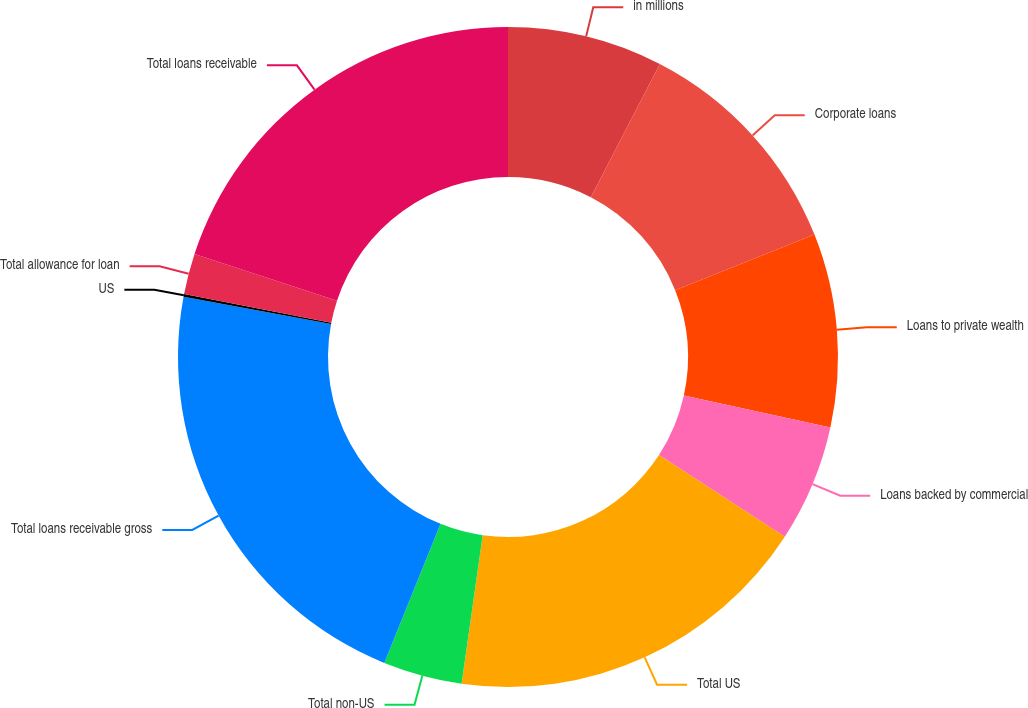Convert chart to OTSL. <chart><loc_0><loc_0><loc_500><loc_500><pie_chart><fcel>in millions<fcel>Corporate loans<fcel>Loans to private wealth<fcel>Loans backed by commercial<fcel>Total US<fcel>Total non-US<fcel>Total loans receivable gross<fcel>US<fcel>Total allowance for loan<fcel>Total loans receivable<nl><fcel>7.61%<fcel>11.34%<fcel>9.47%<fcel>5.74%<fcel>18.08%<fcel>3.87%<fcel>21.81%<fcel>0.13%<fcel>2.0%<fcel>19.94%<nl></chart> 